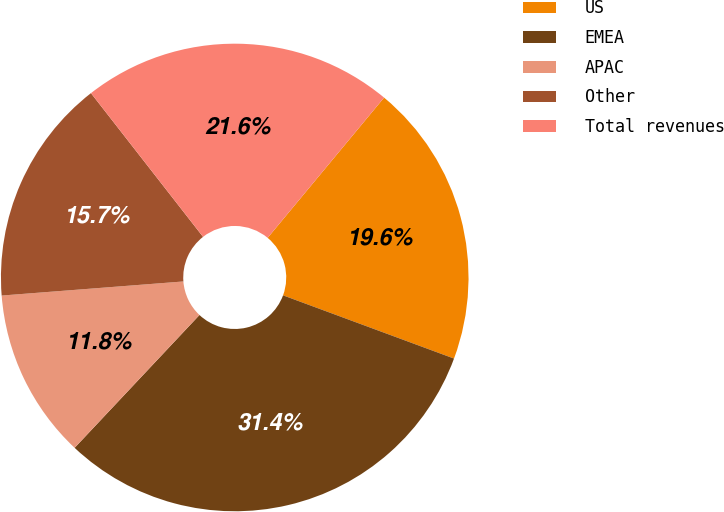Convert chart. <chart><loc_0><loc_0><loc_500><loc_500><pie_chart><fcel>US<fcel>EMEA<fcel>APAC<fcel>Other<fcel>Total revenues<nl><fcel>19.61%<fcel>31.37%<fcel>11.76%<fcel>15.69%<fcel>21.57%<nl></chart> 